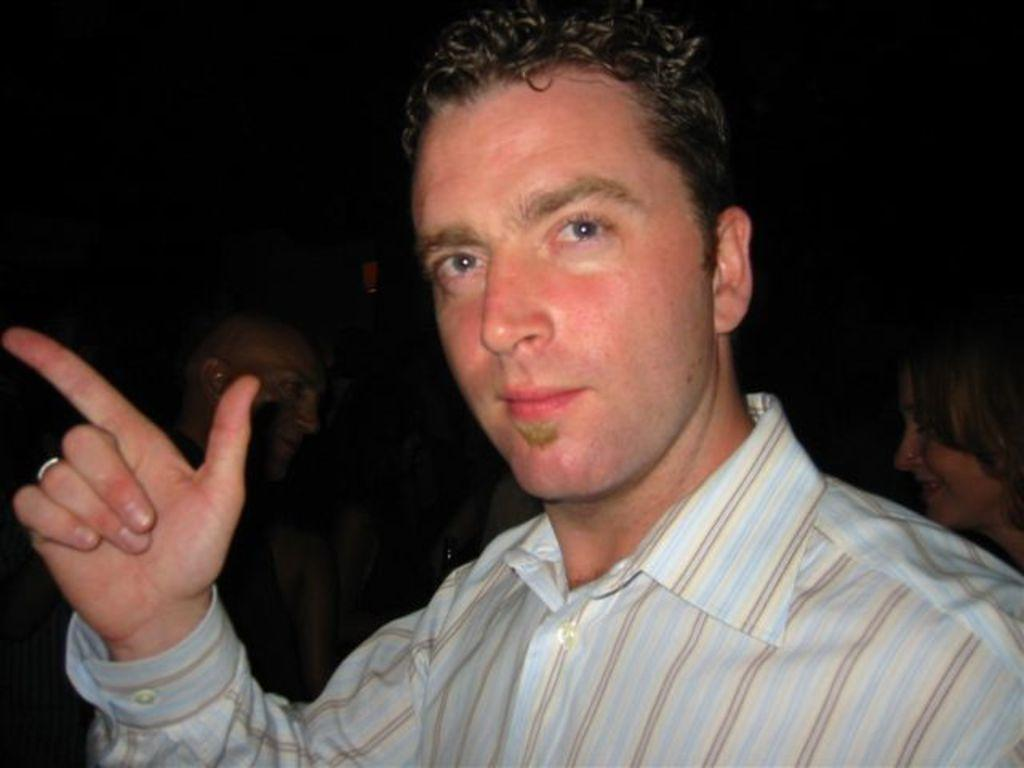Who is present in the image? There is a man in the image. What is the man wearing? The man is wearing a striped shirt. What is the man doing in the image? The man is standing. Are there any other people in the image? Yes, there are other people standing in the image. How would you describe the background of the image? The background of the image is blurry. Can you tell me how many donkeys are present in the image? There are no donkeys present in the image. What part of the man's body is missing in the image? There is no indication that any part of the man's body is missing in the image. 